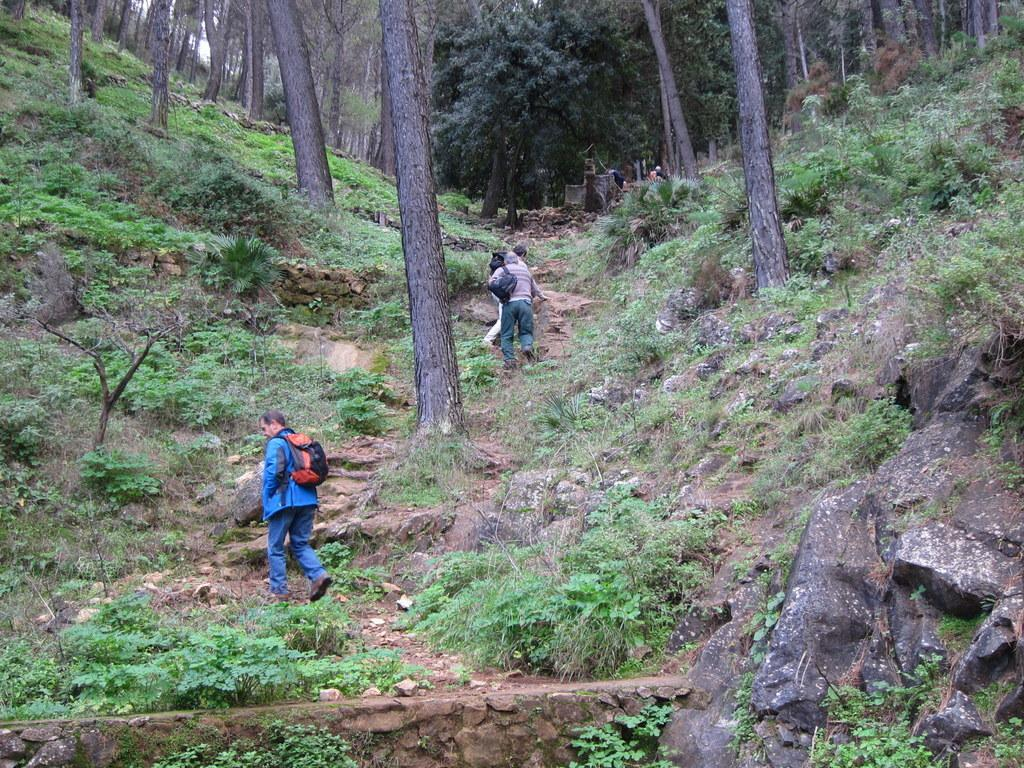What can be seen in the foreground of the image? In the foreground of the image, there are rocks, plants, and people walking on a path. What surrounds the path in the foreground? Tree trunks are present on either side of the path. What is visible at the top of the image? Trees are visible at the top of the image. What type of protest is taking place in the image? There is no protest present in the image; it features rocks, plants, people walking on a path, and trees. Can you tell me how many ministers are visible in the image? There are no ministers present in the image. 